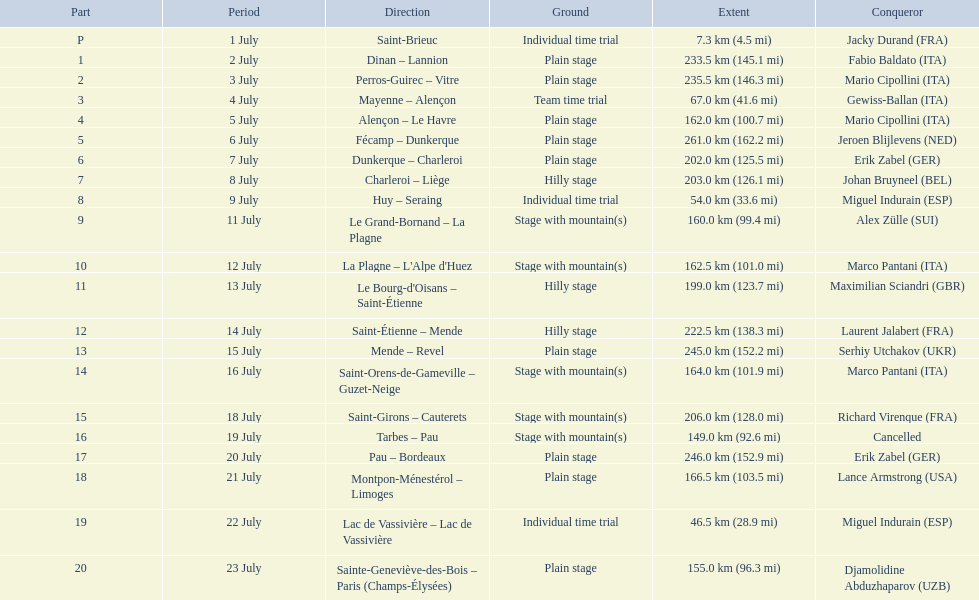What are the dates? 1 July, 2 July, 3 July, 4 July, 5 July, 6 July, 7 July, 8 July, 9 July, 11 July, 12 July, 13 July, 14 July, 15 July, 16 July, 18 July, 19 July, 20 July, 21 July, 22 July, 23 July. What is the length on 8 july? 203.0 km (126.1 mi). 